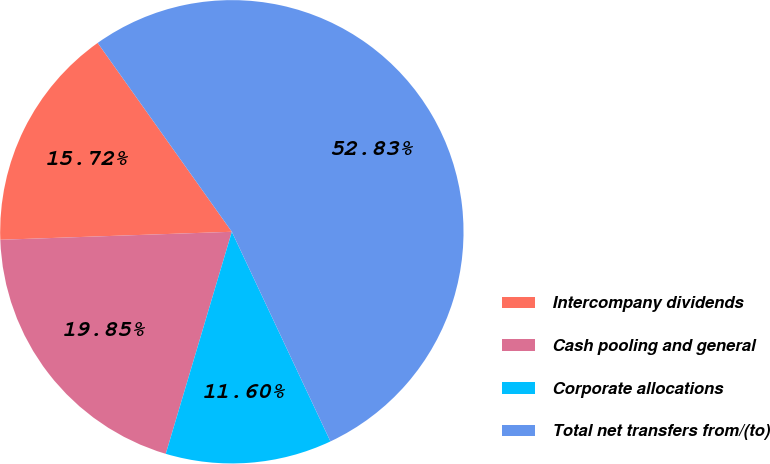Convert chart. <chart><loc_0><loc_0><loc_500><loc_500><pie_chart><fcel>Intercompany dividends<fcel>Cash pooling and general<fcel>Corporate allocations<fcel>Total net transfers from/(to)<nl><fcel>15.72%<fcel>19.85%<fcel>11.6%<fcel>52.84%<nl></chart> 